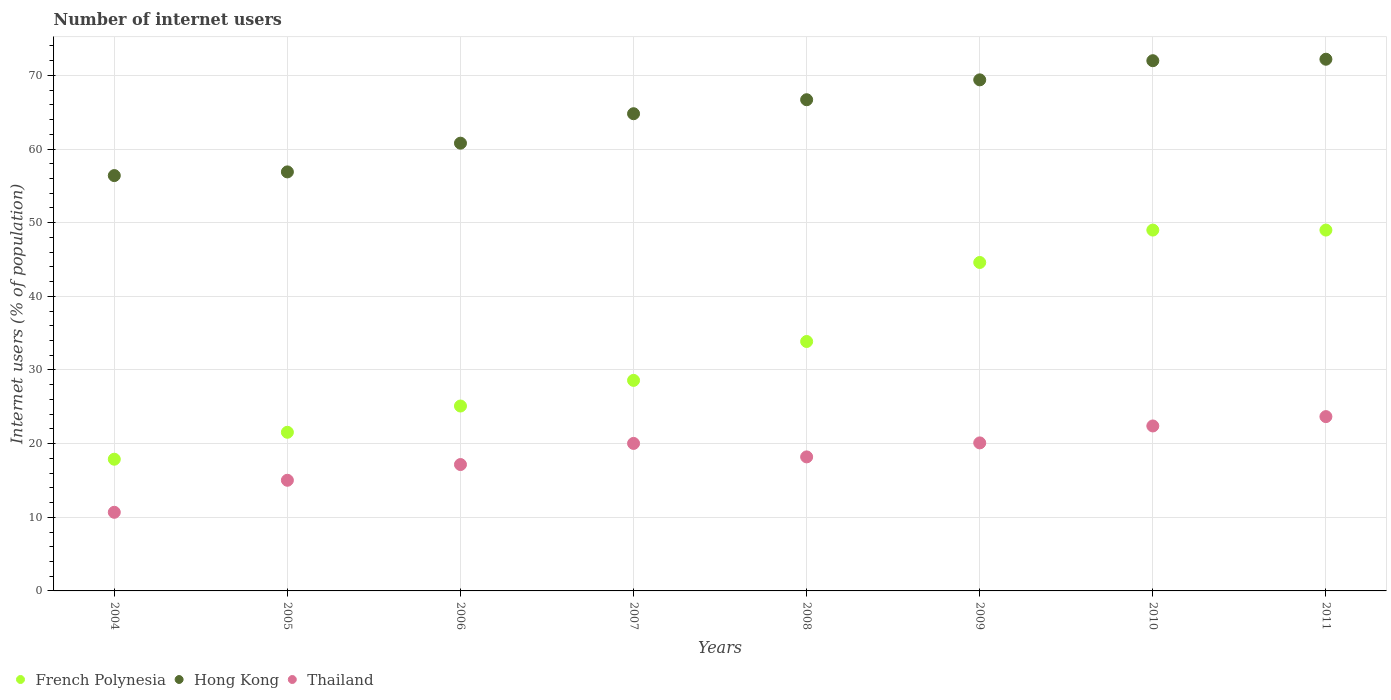How many different coloured dotlines are there?
Your response must be concise. 3. Is the number of dotlines equal to the number of legend labels?
Your answer should be very brief. Yes. What is the number of internet users in Thailand in 2005?
Ensure brevity in your answer.  15.03. Across all years, what is the maximum number of internet users in Thailand?
Give a very brief answer. 23.67. Across all years, what is the minimum number of internet users in Hong Kong?
Provide a short and direct response. 56.4. In which year was the number of internet users in French Polynesia maximum?
Keep it short and to the point. 2010. In which year was the number of internet users in French Polynesia minimum?
Offer a terse response. 2004. What is the total number of internet users in Thailand in the graph?
Your answer should be compact. 147.26. What is the difference between the number of internet users in Thailand in 2004 and that in 2011?
Offer a very short reply. -12.99. What is the difference between the number of internet users in Thailand in 2011 and the number of internet users in Hong Kong in 2009?
Give a very brief answer. -45.73. What is the average number of internet users in Hong Kong per year?
Keep it short and to the point. 64.9. In the year 2010, what is the difference between the number of internet users in Hong Kong and number of internet users in French Polynesia?
Your answer should be compact. 23. What is the ratio of the number of internet users in French Polynesia in 2007 to that in 2009?
Your answer should be compact. 0.64. Is the number of internet users in French Polynesia in 2008 less than that in 2010?
Provide a succinct answer. Yes. What is the difference between the highest and the second highest number of internet users in French Polynesia?
Offer a terse response. 0. What is the difference between the highest and the lowest number of internet users in Thailand?
Your answer should be very brief. 12.99. In how many years, is the number of internet users in French Polynesia greater than the average number of internet users in French Polynesia taken over all years?
Your response must be concise. 4. Is the sum of the number of internet users in Hong Kong in 2004 and 2007 greater than the maximum number of internet users in French Polynesia across all years?
Your answer should be very brief. Yes. Is it the case that in every year, the sum of the number of internet users in Thailand and number of internet users in French Polynesia  is greater than the number of internet users in Hong Kong?
Provide a succinct answer. No. Is the number of internet users in Hong Kong strictly greater than the number of internet users in French Polynesia over the years?
Your response must be concise. Yes. Is the number of internet users in Hong Kong strictly less than the number of internet users in French Polynesia over the years?
Your response must be concise. No. How many dotlines are there?
Give a very brief answer. 3. How many years are there in the graph?
Provide a succinct answer. 8. What is the difference between two consecutive major ticks on the Y-axis?
Your answer should be very brief. 10. Are the values on the major ticks of Y-axis written in scientific E-notation?
Offer a terse response. No. Does the graph contain grids?
Offer a very short reply. Yes. Where does the legend appear in the graph?
Give a very brief answer. Bottom left. How many legend labels are there?
Your answer should be compact. 3. What is the title of the graph?
Offer a terse response. Number of internet users. What is the label or title of the Y-axis?
Offer a terse response. Internet users (% of population). What is the Internet users (% of population) in French Polynesia in 2004?
Ensure brevity in your answer.  17.88. What is the Internet users (% of population) of Hong Kong in 2004?
Your answer should be very brief. 56.4. What is the Internet users (% of population) in Thailand in 2004?
Offer a terse response. 10.68. What is the Internet users (% of population) in French Polynesia in 2005?
Your answer should be compact. 21.54. What is the Internet users (% of population) in Hong Kong in 2005?
Ensure brevity in your answer.  56.9. What is the Internet users (% of population) in Thailand in 2005?
Offer a very short reply. 15.03. What is the Internet users (% of population) of French Polynesia in 2006?
Your answer should be compact. 25.11. What is the Internet users (% of population) of Hong Kong in 2006?
Provide a succinct answer. 60.8. What is the Internet users (% of population) of Thailand in 2006?
Offer a very short reply. 17.16. What is the Internet users (% of population) of French Polynesia in 2007?
Offer a terse response. 28.59. What is the Internet users (% of population) in Hong Kong in 2007?
Ensure brevity in your answer.  64.8. What is the Internet users (% of population) of Thailand in 2007?
Provide a succinct answer. 20.03. What is the Internet users (% of population) of French Polynesia in 2008?
Provide a short and direct response. 33.87. What is the Internet users (% of population) of Hong Kong in 2008?
Ensure brevity in your answer.  66.7. What is the Internet users (% of population) in French Polynesia in 2009?
Your answer should be compact. 44.6. What is the Internet users (% of population) in Hong Kong in 2009?
Provide a succinct answer. 69.4. What is the Internet users (% of population) in Thailand in 2009?
Provide a succinct answer. 20.1. What is the Internet users (% of population) in French Polynesia in 2010?
Provide a succinct answer. 49. What is the Internet users (% of population) of Thailand in 2010?
Ensure brevity in your answer.  22.4. What is the Internet users (% of population) of French Polynesia in 2011?
Provide a succinct answer. 49. What is the Internet users (% of population) in Hong Kong in 2011?
Your response must be concise. 72.2. What is the Internet users (% of population) in Thailand in 2011?
Offer a terse response. 23.67. Across all years, what is the maximum Internet users (% of population) of Hong Kong?
Your answer should be very brief. 72.2. Across all years, what is the maximum Internet users (% of population) of Thailand?
Your response must be concise. 23.67. Across all years, what is the minimum Internet users (% of population) of French Polynesia?
Provide a succinct answer. 17.88. Across all years, what is the minimum Internet users (% of population) of Hong Kong?
Provide a succinct answer. 56.4. Across all years, what is the minimum Internet users (% of population) of Thailand?
Ensure brevity in your answer.  10.68. What is the total Internet users (% of population) in French Polynesia in the graph?
Ensure brevity in your answer.  269.59. What is the total Internet users (% of population) in Hong Kong in the graph?
Your response must be concise. 519.2. What is the total Internet users (% of population) in Thailand in the graph?
Keep it short and to the point. 147.26. What is the difference between the Internet users (% of population) in French Polynesia in 2004 and that in 2005?
Make the answer very short. -3.66. What is the difference between the Internet users (% of population) in Hong Kong in 2004 and that in 2005?
Give a very brief answer. -0.5. What is the difference between the Internet users (% of population) of Thailand in 2004 and that in 2005?
Provide a short and direct response. -4.35. What is the difference between the Internet users (% of population) in French Polynesia in 2004 and that in 2006?
Your answer should be very brief. -7.22. What is the difference between the Internet users (% of population) in Hong Kong in 2004 and that in 2006?
Provide a succinct answer. -4.4. What is the difference between the Internet users (% of population) of Thailand in 2004 and that in 2006?
Offer a very short reply. -6.48. What is the difference between the Internet users (% of population) in French Polynesia in 2004 and that in 2007?
Make the answer very short. -10.71. What is the difference between the Internet users (% of population) of Hong Kong in 2004 and that in 2007?
Offer a terse response. -8.4. What is the difference between the Internet users (% of population) of Thailand in 2004 and that in 2007?
Your answer should be compact. -9.35. What is the difference between the Internet users (% of population) in French Polynesia in 2004 and that in 2008?
Make the answer very short. -15.99. What is the difference between the Internet users (% of population) of Hong Kong in 2004 and that in 2008?
Your answer should be very brief. -10.3. What is the difference between the Internet users (% of population) in Thailand in 2004 and that in 2008?
Make the answer very short. -7.52. What is the difference between the Internet users (% of population) in French Polynesia in 2004 and that in 2009?
Provide a succinct answer. -26.72. What is the difference between the Internet users (% of population) in Hong Kong in 2004 and that in 2009?
Your answer should be compact. -13. What is the difference between the Internet users (% of population) of Thailand in 2004 and that in 2009?
Offer a terse response. -9.42. What is the difference between the Internet users (% of population) of French Polynesia in 2004 and that in 2010?
Your answer should be compact. -31.12. What is the difference between the Internet users (% of population) of Hong Kong in 2004 and that in 2010?
Provide a short and direct response. -15.6. What is the difference between the Internet users (% of population) in Thailand in 2004 and that in 2010?
Your response must be concise. -11.72. What is the difference between the Internet users (% of population) in French Polynesia in 2004 and that in 2011?
Keep it short and to the point. -31.12. What is the difference between the Internet users (% of population) of Hong Kong in 2004 and that in 2011?
Provide a succinct answer. -15.8. What is the difference between the Internet users (% of population) of Thailand in 2004 and that in 2011?
Give a very brief answer. -12.99. What is the difference between the Internet users (% of population) of French Polynesia in 2005 and that in 2006?
Your answer should be very brief. -3.57. What is the difference between the Internet users (% of population) of Hong Kong in 2005 and that in 2006?
Provide a succinct answer. -3.9. What is the difference between the Internet users (% of population) in Thailand in 2005 and that in 2006?
Provide a succinct answer. -2.13. What is the difference between the Internet users (% of population) in French Polynesia in 2005 and that in 2007?
Keep it short and to the point. -7.05. What is the difference between the Internet users (% of population) of Thailand in 2005 and that in 2007?
Ensure brevity in your answer.  -5. What is the difference between the Internet users (% of population) in French Polynesia in 2005 and that in 2008?
Your answer should be compact. -12.33. What is the difference between the Internet users (% of population) in Thailand in 2005 and that in 2008?
Offer a terse response. -3.17. What is the difference between the Internet users (% of population) of French Polynesia in 2005 and that in 2009?
Your answer should be compact. -23.06. What is the difference between the Internet users (% of population) of Thailand in 2005 and that in 2009?
Make the answer very short. -5.07. What is the difference between the Internet users (% of population) in French Polynesia in 2005 and that in 2010?
Keep it short and to the point. -27.46. What is the difference between the Internet users (% of population) of Hong Kong in 2005 and that in 2010?
Give a very brief answer. -15.1. What is the difference between the Internet users (% of population) in Thailand in 2005 and that in 2010?
Make the answer very short. -7.37. What is the difference between the Internet users (% of population) of French Polynesia in 2005 and that in 2011?
Make the answer very short. -27.46. What is the difference between the Internet users (% of population) in Hong Kong in 2005 and that in 2011?
Give a very brief answer. -15.3. What is the difference between the Internet users (% of population) in Thailand in 2005 and that in 2011?
Your answer should be compact. -8.64. What is the difference between the Internet users (% of population) of French Polynesia in 2006 and that in 2007?
Make the answer very short. -3.48. What is the difference between the Internet users (% of population) of Hong Kong in 2006 and that in 2007?
Keep it short and to the point. -4. What is the difference between the Internet users (% of population) of Thailand in 2006 and that in 2007?
Offer a very short reply. -2.87. What is the difference between the Internet users (% of population) in French Polynesia in 2006 and that in 2008?
Your answer should be compact. -8.76. What is the difference between the Internet users (% of population) of Hong Kong in 2006 and that in 2008?
Your answer should be compact. -5.9. What is the difference between the Internet users (% of population) of Thailand in 2006 and that in 2008?
Make the answer very short. -1.04. What is the difference between the Internet users (% of population) in French Polynesia in 2006 and that in 2009?
Provide a short and direct response. -19.49. What is the difference between the Internet users (% of population) in Hong Kong in 2006 and that in 2009?
Your response must be concise. -8.6. What is the difference between the Internet users (% of population) of Thailand in 2006 and that in 2009?
Make the answer very short. -2.94. What is the difference between the Internet users (% of population) in French Polynesia in 2006 and that in 2010?
Your response must be concise. -23.89. What is the difference between the Internet users (% of population) in Hong Kong in 2006 and that in 2010?
Provide a succinct answer. -11.2. What is the difference between the Internet users (% of population) of Thailand in 2006 and that in 2010?
Your response must be concise. -5.24. What is the difference between the Internet users (% of population) of French Polynesia in 2006 and that in 2011?
Provide a short and direct response. -23.89. What is the difference between the Internet users (% of population) in Thailand in 2006 and that in 2011?
Your answer should be compact. -6.51. What is the difference between the Internet users (% of population) of French Polynesia in 2007 and that in 2008?
Ensure brevity in your answer.  -5.28. What is the difference between the Internet users (% of population) in Hong Kong in 2007 and that in 2008?
Your response must be concise. -1.9. What is the difference between the Internet users (% of population) in Thailand in 2007 and that in 2008?
Keep it short and to the point. 1.83. What is the difference between the Internet users (% of population) in French Polynesia in 2007 and that in 2009?
Offer a very short reply. -16.01. What is the difference between the Internet users (% of population) in Thailand in 2007 and that in 2009?
Make the answer very short. -0.07. What is the difference between the Internet users (% of population) of French Polynesia in 2007 and that in 2010?
Give a very brief answer. -20.41. What is the difference between the Internet users (% of population) of Thailand in 2007 and that in 2010?
Give a very brief answer. -2.37. What is the difference between the Internet users (% of population) in French Polynesia in 2007 and that in 2011?
Keep it short and to the point. -20.41. What is the difference between the Internet users (% of population) of Hong Kong in 2007 and that in 2011?
Keep it short and to the point. -7.4. What is the difference between the Internet users (% of population) in Thailand in 2007 and that in 2011?
Your answer should be compact. -3.64. What is the difference between the Internet users (% of population) of French Polynesia in 2008 and that in 2009?
Your response must be concise. -10.73. What is the difference between the Internet users (% of population) of French Polynesia in 2008 and that in 2010?
Your answer should be very brief. -15.13. What is the difference between the Internet users (% of population) of Hong Kong in 2008 and that in 2010?
Provide a succinct answer. -5.3. What is the difference between the Internet users (% of population) of French Polynesia in 2008 and that in 2011?
Keep it short and to the point. -15.13. What is the difference between the Internet users (% of population) in Thailand in 2008 and that in 2011?
Offer a very short reply. -5.47. What is the difference between the Internet users (% of population) of French Polynesia in 2009 and that in 2010?
Your response must be concise. -4.4. What is the difference between the Internet users (% of population) in Hong Kong in 2009 and that in 2010?
Your answer should be compact. -2.6. What is the difference between the Internet users (% of population) in Thailand in 2009 and that in 2011?
Your answer should be compact. -3.57. What is the difference between the Internet users (% of population) of Thailand in 2010 and that in 2011?
Your response must be concise. -1.27. What is the difference between the Internet users (% of population) in French Polynesia in 2004 and the Internet users (% of population) in Hong Kong in 2005?
Ensure brevity in your answer.  -39.02. What is the difference between the Internet users (% of population) in French Polynesia in 2004 and the Internet users (% of population) in Thailand in 2005?
Provide a short and direct response. 2.86. What is the difference between the Internet users (% of population) of Hong Kong in 2004 and the Internet users (% of population) of Thailand in 2005?
Give a very brief answer. 41.37. What is the difference between the Internet users (% of population) of French Polynesia in 2004 and the Internet users (% of population) of Hong Kong in 2006?
Provide a short and direct response. -42.92. What is the difference between the Internet users (% of population) of French Polynesia in 2004 and the Internet users (% of population) of Thailand in 2006?
Keep it short and to the point. 0.72. What is the difference between the Internet users (% of population) of Hong Kong in 2004 and the Internet users (% of population) of Thailand in 2006?
Provide a short and direct response. 39.24. What is the difference between the Internet users (% of population) of French Polynesia in 2004 and the Internet users (% of population) of Hong Kong in 2007?
Offer a very short reply. -46.92. What is the difference between the Internet users (% of population) in French Polynesia in 2004 and the Internet users (% of population) in Thailand in 2007?
Ensure brevity in your answer.  -2.15. What is the difference between the Internet users (% of population) of Hong Kong in 2004 and the Internet users (% of population) of Thailand in 2007?
Give a very brief answer. 36.37. What is the difference between the Internet users (% of population) in French Polynesia in 2004 and the Internet users (% of population) in Hong Kong in 2008?
Make the answer very short. -48.82. What is the difference between the Internet users (% of population) in French Polynesia in 2004 and the Internet users (% of population) in Thailand in 2008?
Your answer should be very brief. -0.32. What is the difference between the Internet users (% of population) of Hong Kong in 2004 and the Internet users (% of population) of Thailand in 2008?
Keep it short and to the point. 38.2. What is the difference between the Internet users (% of population) in French Polynesia in 2004 and the Internet users (% of population) in Hong Kong in 2009?
Offer a terse response. -51.52. What is the difference between the Internet users (% of population) of French Polynesia in 2004 and the Internet users (% of population) of Thailand in 2009?
Your answer should be compact. -2.22. What is the difference between the Internet users (% of population) in Hong Kong in 2004 and the Internet users (% of population) in Thailand in 2009?
Offer a very short reply. 36.3. What is the difference between the Internet users (% of population) in French Polynesia in 2004 and the Internet users (% of population) in Hong Kong in 2010?
Offer a terse response. -54.12. What is the difference between the Internet users (% of population) of French Polynesia in 2004 and the Internet users (% of population) of Thailand in 2010?
Offer a terse response. -4.52. What is the difference between the Internet users (% of population) in Hong Kong in 2004 and the Internet users (% of population) in Thailand in 2010?
Your answer should be compact. 34. What is the difference between the Internet users (% of population) in French Polynesia in 2004 and the Internet users (% of population) in Hong Kong in 2011?
Your answer should be compact. -54.32. What is the difference between the Internet users (% of population) in French Polynesia in 2004 and the Internet users (% of population) in Thailand in 2011?
Ensure brevity in your answer.  -5.79. What is the difference between the Internet users (% of population) in Hong Kong in 2004 and the Internet users (% of population) in Thailand in 2011?
Provide a short and direct response. 32.73. What is the difference between the Internet users (% of population) in French Polynesia in 2005 and the Internet users (% of population) in Hong Kong in 2006?
Your answer should be very brief. -39.26. What is the difference between the Internet users (% of population) in French Polynesia in 2005 and the Internet users (% of population) in Thailand in 2006?
Make the answer very short. 4.38. What is the difference between the Internet users (% of population) of Hong Kong in 2005 and the Internet users (% of population) of Thailand in 2006?
Make the answer very short. 39.74. What is the difference between the Internet users (% of population) of French Polynesia in 2005 and the Internet users (% of population) of Hong Kong in 2007?
Your answer should be very brief. -43.26. What is the difference between the Internet users (% of population) in French Polynesia in 2005 and the Internet users (% of population) in Thailand in 2007?
Make the answer very short. 1.51. What is the difference between the Internet users (% of population) of Hong Kong in 2005 and the Internet users (% of population) of Thailand in 2007?
Offer a very short reply. 36.87. What is the difference between the Internet users (% of population) in French Polynesia in 2005 and the Internet users (% of population) in Hong Kong in 2008?
Your answer should be very brief. -45.16. What is the difference between the Internet users (% of population) in French Polynesia in 2005 and the Internet users (% of population) in Thailand in 2008?
Provide a short and direct response. 3.34. What is the difference between the Internet users (% of population) of Hong Kong in 2005 and the Internet users (% of population) of Thailand in 2008?
Provide a short and direct response. 38.7. What is the difference between the Internet users (% of population) in French Polynesia in 2005 and the Internet users (% of population) in Hong Kong in 2009?
Provide a short and direct response. -47.86. What is the difference between the Internet users (% of population) in French Polynesia in 2005 and the Internet users (% of population) in Thailand in 2009?
Offer a very short reply. 1.44. What is the difference between the Internet users (% of population) of Hong Kong in 2005 and the Internet users (% of population) of Thailand in 2009?
Ensure brevity in your answer.  36.8. What is the difference between the Internet users (% of population) of French Polynesia in 2005 and the Internet users (% of population) of Hong Kong in 2010?
Offer a terse response. -50.46. What is the difference between the Internet users (% of population) in French Polynesia in 2005 and the Internet users (% of population) in Thailand in 2010?
Give a very brief answer. -0.86. What is the difference between the Internet users (% of population) of Hong Kong in 2005 and the Internet users (% of population) of Thailand in 2010?
Offer a terse response. 34.5. What is the difference between the Internet users (% of population) in French Polynesia in 2005 and the Internet users (% of population) in Hong Kong in 2011?
Your response must be concise. -50.66. What is the difference between the Internet users (% of population) of French Polynesia in 2005 and the Internet users (% of population) of Thailand in 2011?
Your response must be concise. -2.13. What is the difference between the Internet users (% of population) in Hong Kong in 2005 and the Internet users (% of population) in Thailand in 2011?
Your response must be concise. 33.23. What is the difference between the Internet users (% of population) of French Polynesia in 2006 and the Internet users (% of population) of Hong Kong in 2007?
Your answer should be very brief. -39.69. What is the difference between the Internet users (% of population) of French Polynesia in 2006 and the Internet users (% of population) of Thailand in 2007?
Your answer should be compact. 5.08. What is the difference between the Internet users (% of population) in Hong Kong in 2006 and the Internet users (% of population) in Thailand in 2007?
Your answer should be compact. 40.77. What is the difference between the Internet users (% of population) of French Polynesia in 2006 and the Internet users (% of population) of Hong Kong in 2008?
Make the answer very short. -41.59. What is the difference between the Internet users (% of population) of French Polynesia in 2006 and the Internet users (% of population) of Thailand in 2008?
Your response must be concise. 6.91. What is the difference between the Internet users (% of population) in Hong Kong in 2006 and the Internet users (% of population) in Thailand in 2008?
Offer a very short reply. 42.6. What is the difference between the Internet users (% of population) of French Polynesia in 2006 and the Internet users (% of population) of Hong Kong in 2009?
Your answer should be compact. -44.29. What is the difference between the Internet users (% of population) of French Polynesia in 2006 and the Internet users (% of population) of Thailand in 2009?
Make the answer very short. 5.01. What is the difference between the Internet users (% of population) of Hong Kong in 2006 and the Internet users (% of population) of Thailand in 2009?
Provide a succinct answer. 40.7. What is the difference between the Internet users (% of population) of French Polynesia in 2006 and the Internet users (% of population) of Hong Kong in 2010?
Give a very brief answer. -46.89. What is the difference between the Internet users (% of population) in French Polynesia in 2006 and the Internet users (% of population) in Thailand in 2010?
Your response must be concise. 2.71. What is the difference between the Internet users (% of population) in Hong Kong in 2006 and the Internet users (% of population) in Thailand in 2010?
Your answer should be compact. 38.4. What is the difference between the Internet users (% of population) of French Polynesia in 2006 and the Internet users (% of population) of Hong Kong in 2011?
Your answer should be compact. -47.09. What is the difference between the Internet users (% of population) in French Polynesia in 2006 and the Internet users (% of population) in Thailand in 2011?
Provide a short and direct response. 1.44. What is the difference between the Internet users (% of population) in Hong Kong in 2006 and the Internet users (% of population) in Thailand in 2011?
Keep it short and to the point. 37.13. What is the difference between the Internet users (% of population) of French Polynesia in 2007 and the Internet users (% of population) of Hong Kong in 2008?
Your answer should be very brief. -38.11. What is the difference between the Internet users (% of population) of French Polynesia in 2007 and the Internet users (% of population) of Thailand in 2008?
Make the answer very short. 10.39. What is the difference between the Internet users (% of population) of Hong Kong in 2007 and the Internet users (% of population) of Thailand in 2008?
Offer a very short reply. 46.6. What is the difference between the Internet users (% of population) of French Polynesia in 2007 and the Internet users (% of population) of Hong Kong in 2009?
Offer a very short reply. -40.81. What is the difference between the Internet users (% of population) in French Polynesia in 2007 and the Internet users (% of population) in Thailand in 2009?
Keep it short and to the point. 8.49. What is the difference between the Internet users (% of population) of Hong Kong in 2007 and the Internet users (% of population) of Thailand in 2009?
Provide a short and direct response. 44.7. What is the difference between the Internet users (% of population) in French Polynesia in 2007 and the Internet users (% of population) in Hong Kong in 2010?
Keep it short and to the point. -43.41. What is the difference between the Internet users (% of population) of French Polynesia in 2007 and the Internet users (% of population) of Thailand in 2010?
Your answer should be compact. 6.19. What is the difference between the Internet users (% of population) in Hong Kong in 2007 and the Internet users (% of population) in Thailand in 2010?
Offer a very short reply. 42.4. What is the difference between the Internet users (% of population) of French Polynesia in 2007 and the Internet users (% of population) of Hong Kong in 2011?
Make the answer very short. -43.61. What is the difference between the Internet users (% of population) in French Polynesia in 2007 and the Internet users (% of population) in Thailand in 2011?
Provide a succinct answer. 4.92. What is the difference between the Internet users (% of population) in Hong Kong in 2007 and the Internet users (% of population) in Thailand in 2011?
Keep it short and to the point. 41.13. What is the difference between the Internet users (% of population) in French Polynesia in 2008 and the Internet users (% of population) in Hong Kong in 2009?
Provide a succinct answer. -35.53. What is the difference between the Internet users (% of population) of French Polynesia in 2008 and the Internet users (% of population) of Thailand in 2009?
Your answer should be very brief. 13.77. What is the difference between the Internet users (% of population) in Hong Kong in 2008 and the Internet users (% of population) in Thailand in 2009?
Provide a short and direct response. 46.6. What is the difference between the Internet users (% of population) in French Polynesia in 2008 and the Internet users (% of population) in Hong Kong in 2010?
Provide a short and direct response. -38.13. What is the difference between the Internet users (% of population) in French Polynesia in 2008 and the Internet users (% of population) in Thailand in 2010?
Your answer should be compact. 11.47. What is the difference between the Internet users (% of population) of Hong Kong in 2008 and the Internet users (% of population) of Thailand in 2010?
Provide a succinct answer. 44.3. What is the difference between the Internet users (% of population) in French Polynesia in 2008 and the Internet users (% of population) in Hong Kong in 2011?
Ensure brevity in your answer.  -38.33. What is the difference between the Internet users (% of population) in French Polynesia in 2008 and the Internet users (% of population) in Thailand in 2011?
Make the answer very short. 10.2. What is the difference between the Internet users (% of population) in Hong Kong in 2008 and the Internet users (% of population) in Thailand in 2011?
Provide a succinct answer. 43.03. What is the difference between the Internet users (% of population) of French Polynesia in 2009 and the Internet users (% of population) of Hong Kong in 2010?
Provide a succinct answer. -27.4. What is the difference between the Internet users (% of population) in Hong Kong in 2009 and the Internet users (% of population) in Thailand in 2010?
Make the answer very short. 47. What is the difference between the Internet users (% of population) in French Polynesia in 2009 and the Internet users (% of population) in Hong Kong in 2011?
Give a very brief answer. -27.6. What is the difference between the Internet users (% of population) of French Polynesia in 2009 and the Internet users (% of population) of Thailand in 2011?
Your response must be concise. 20.93. What is the difference between the Internet users (% of population) in Hong Kong in 2009 and the Internet users (% of population) in Thailand in 2011?
Make the answer very short. 45.73. What is the difference between the Internet users (% of population) of French Polynesia in 2010 and the Internet users (% of population) of Hong Kong in 2011?
Keep it short and to the point. -23.2. What is the difference between the Internet users (% of population) in French Polynesia in 2010 and the Internet users (% of population) in Thailand in 2011?
Your answer should be compact. 25.33. What is the difference between the Internet users (% of population) in Hong Kong in 2010 and the Internet users (% of population) in Thailand in 2011?
Provide a short and direct response. 48.33. What is the average Internet users (% of population) in French Polynesia per year?
Your answer should be very brief. 33.7. What is the average Internet users (% of population) in Hong Kong per year?
Your answer should be very brief. 64.9. What is the average Internet users (% of population) of Thailand per year?
Provide a short and direct response. 18.41. In the year 2004, what is the difference between the Internet users (% of population) of French Polynesia and Internet users (% of population) of Hong Kong?
Your response must be concise. -38.52. In the year 2004, what is the difference between the Internet users (% of population) of French Polynesia and Internet users (% of population) of Thailand?
Provide a short and direct response. 7.21. In the year 2004, what is the difference between the Internet users (% of population) in Hong Kong and Internet users (% of population) in Thailand?
Provide a short and direct response. 45.72. In the year 2005, what is the difference between the Internet users (% of population) of French Polynesia and Internet users (% of population) of Hong Kong?
Make the answer very short. -35.36. In the year 2005, what is the difference between the Internet users (% of population) in French Polynesia and Internet users (% of population) in Thailand?
Provide a short and direct response. 6.52. In the year 2005, what is the difference between the Internet users (% of population) in Hong Kong and Internet users (% of population) in Thailand?
Your answer should be very brief. 41.87. In the year 2006, what is the difference between the Internet users (% of population) of French Polynesia and Internet users (% of population) of Hong Kong?
Keep it short and to the point. -35.69. In the year 2006, what is the difference between the Internet users (% of population) in French Polynesia and Internet users (% of population) in Thailand?
Provide a succinct answer. 7.95. In the year 2006, what is the difference between the Internet users (% of population) in Hong Kong and Internet users (% of population) in Thailand?
Ensure brevity in your answer.  43.64. In the year 2007, what is the difference between the Internet users (% of population) in French Polynesia and Internet users (% of population) in Hong Kong?
Your answer should be compact. -36.21. In the year 2007, what is the difference between the Internet users (% of population) in French Polynesia and Internet users (% of population) in Thailand?
Give a very brief answer. 8.56. In the year 2007, what is the difference between the Internet users (% of population) in Hong Kong and Internet users (% of population) in Thailand?
Provide a succinct answer. 44.77. In the year 2008, what is the difference between the Internet users (% of population) of French Polynesia and Internet users (% of population) of Hong Kong?
Offer a very short reply. -32.83. In the year 2008, what is the difference between the Internet users (% of population) of French Polynesia and Internet users (% of population) of Thailand?
Give a very brief answer. 15.67. In the year 2008, what is the difference between the Internet users (% of population) of Hong Kong and Internet users (% of population) of Thailand?
Your answer should be very brief. 48.5. In the year 2009, what is the difference between the Internet users (% of population) in French Polynesia and Internet users (% of population) in Hong Kong?
Your answer should be compact. -24.8. In the year 2009, what is the difference between the Internet users (% of population) of French Polynesia and Internet users (% of population) of Thailand?
Offer a terse response. 24.5. In the year 2009, what is the difference between the Internet users (% of population) in Hong Kong and Internet users (% of population) in Thailand?
Your response must be concise. 49.3. In the year 2010, what is the difference between the Internet users (% of population) of French Polynesia and Internet users (% of population) of Hong Kong?
Provide a short and direct response. -23. In the year 2010, what is the difference between the Internet users (% of population) of French Polynesia and Internet users (% of population) of Thailand?
Keep it short and to the point. 26.6. In the year 2010, what is the difference between the Internet users (% of population) in Hong Kong and Internet users (% of population) in Thailand?
Keep it short and to the point. 49.6. In the year 2011, what is the difference between the Internet users (% of population) in French Polynesia and Internet users (% of population) in Hong Kong?
Give a very brief answer. -23.2. In the year 2011, what is the difference between the Internet users (% of population) in French Polynesia and Internet users (% of population) in Thailand?
Your response must be concise. 25.33. In the year 2011, what is the difference between the Internet users (% of population) of Hong Kong and Internet users (% of population) of Thailand?
Your answer should be very brief. 48.53. What is the ratio of the Internet users (% of population) of French Polynesia in 2004 to that in 2005?
Your answer should be compact. 0.83. What is the ratio of the Internet users (% of population) of Hong Kong in 2004 to that in 2005?
Ensure brevity in your answer.  0.99. What is the ratio of the Internet users (% of population) in Thailand in 2004 to that in 2005?
Keep it short and to the point. 0.71. What is the ratio of the Internet users (% of population) in French Polynesia in 2004 to that in 2006?
Keep it short and to the point. 0.71. What is the ratio of the Internet users (% of population) in Hong Kong in 2004 to that in 2006?
Your response must be concise. 0.93. What is the ratio of the Internet users (% of population) of Thailand in 2004 to that in 2006?
Give a very brief answer. 0.62. What is the ratio of the Internet users (% of population) of French Polynesia in 2004 to that in 2007?
Your response must be concise. 0.63. What is the ratio of the Internet users (% of population) of Hong Kong in 2004 to that in 2007?
Provide a succinct answer. 0.87. What is the ratio of the Internet users (% of population) in Thailand in 2004 to that in 2007?
Your answer should be compact. 0.53. What is the ratio of the Internet users (% of population) of French Polynesia in 2004 to that in 2008?
Keep it short and to the point. 0.53. What is the ratio of the Internet users (% of population) in Hong Kong in 2004 to that in 2008?
Provide a succinct answer. 0.85. What is the ratio of the Internet users (% of population) of Thailand in 2004 to that in 2008?
Provide a succinct answer. 0.59. What is the ratio of the Internet users (% of population) of French Polynesia in 2004 to that in 2009?
Provide a succinct answer. 0.4. What is the ratio of the Internet users (% of population) of Hong Kong in 2004 to that in 2009?
Keep it short and to the point. 0.81. What is the ratio of the Internet users (% of population) of Thailand in 2004 to that in 2009?
Ensure brevity in your answer.  0.53. What is the ratio of the Internet users (% of population) of French Polynesia in 2004 to that in 2010?
Provide a succinct answer. 0.36. What is the ratio of the Internet users (% of population) in Hong Kong in 2004 to that in 2010?
Your response must be concise. 0.78. What is the ratio of the Internet users (% of population) in Thailand in 2004 to that in 2010?
Offer a terse response. 0.48. What is the ratio of the Internet users (% of population) in French Polynesia in 2004 to that in 2011?
Provide a short and direct response. 0.36. What is the ratio of the Internet users (% of population) of Hong Kong in 2004 to that in 2011?
Your answer should be very brief. 0.78. What is the ratio of the Internet users (% of population) of Thailand in 2004 to that in 2011?
Offer a very short reply. 0.45. What is the ratio of the Internet users (% of population) in French Polynesia in 2005 to that in 2006?
Keep it short and to the point. 0.86. What is the ratio of the Internet users (% of population) of Hong Kong in 2005 to that in 2006?
Provide a succinct answer. 0.94. What is the ratio of the Internet users (% of population) of Thailand in 2005 to that in 2006?
Offer a terse response. 0.88. What is the ratio of the Internet users (% of population) of French Polynesia in 2005 to that in 2007?
Provide a short and direct response. 0.75. What is the ratio of the Internet users (% of population) in Hong Kong in 2005 to that in 2007?
Make the answer very short. 0.88. What is the ratio of the Internet users (% of population) of Thailand in 2005 to that in 2007?
Give a very brief answer. 0.75. What is the ratio of the Internet users (% of population) of French Polynesia in 2005 to that in 2008?
Offer a very short reply. 0.64. What is the ratio of the Internet users (% of population) of Hong Kong in 2005 to that in 2008?
Your answer should be compact. 0.85. What is the ratio of the Internet users (% of population) of Thailand in 2005 to that in 2008?
Your response must be concise. 0.83. What is the ratio of the Internet users (% of population) in French Polynesia in 2005 to that in 2009?
Your answer should be very brief. 0.48. What is the ratio of the Internet users (% of population) in Hong Kong in 2005 to that in 2009?
Your answer should be very brief. 0.82. What is the ratio of the Internet users (% of population) in Thailand in 2005 to that in 2009?
Give a very brief answer. 0.75. What is the ratio of the Internet users (% of population) of French Polynesia in 2005 to that in 2010?
Your answer should be very brief. 0.44. What is the ratio of the Internet users (% of population) in Hong Kong in 2005 to that in 2010?
Provide a short and direct response. 0.79. What is the ratio of the Internet users (% of population) of Thailand in 2005 to that in 2010?
Your answer should be very brief. 0.67. What is the ratio of the Internet users (% of population) in French Polynesia in 2005 to that in 2011?
Your answer should be very brief. 0.44. What is the ratio of the Internet users (% of population) in Hong Kong in 2005 to that in 2011?
Offer a terse response. 0.79. What is the ratio of the Internet users (% of population) of Thailand in 2005 to that in 2011?
Offer a very short reply. 0.63. What is the ratio of the Internet users (% of population) of French Polynesia in 2006 to that in 2007?
Provide a succinct answer. 0.88. What is the ratio of the Internet users (% of population) of Hong Kong in 2006 to that in 2007?
Make the answer very short. 0.94. What is the ratio of the Internet users (% of population) of Thailand in 2006 to that in 2007?
Provide a short and direct response. 0.86. What is the ratio of the Internet users (% of population) in French Polynesia in 2006 to that in 2008?
Offer a very short reply. 0.74. What is the ratio of the Internet users (% of population) in Hong Kong in 2006 to that in 2008?
Provide a short and direct response. 0.91. What is the ratio of the Internet users (% of population) in Thailand in 2006 to that in 2008?
Your response must be concise. 0.94. What is the ratio of the Internet users (% of population) in French Polynesia in 2006 to that in 2009?
Ensure brevity in your answer.  0.56. What is the ratio of the Internet users (% of population) in Hong Kong in 2006 to that in 2009?
Make the answer very short. 0.88. What is the ratio of the Internet users (% of population) of Thailand in 2006 to that in 2009?
Make the answer very short. 0.85. What is the ratio of the Internet users (% of population) in French Polynesia in 2006 to that in 2010?
Offer a very short reply. 0.51. What is the ratio of the Internet users (% of population) in Hong Kong in 2006 to that in 2010?
Provide a short and direct response. 0.84. What is the ratio of the Internet users (% of population) of Thailand in 2006 to that in 2010?
Your answer should be very brief. 0.77. What is the ratio of the Internet users (% of population) in French Polynesia in 2006 to that in 2011?
Your answer should be very brief. 0.51. What is the ratio of the Internet users (% of population) in Hong Kong in 2006 to that in 2011?
Offer a terse response. 0.84. What is the ratio of the Internet users (% of population) of Thailand in 2006 to that in 2011?
Ensure brevity in your answer.  0.72. What is the ratio of the Internet users (% of population) of French Polynesia in 2007 to that in 2008?
Provide a succinct answer. 0.84. What is the ratio of the Internet users (% of population) in Hong Kong in 2007 to that in 2008?
Your response must be concise. 0.97. What is the ratio of the Internet users (% of population) in Thailand in 2007 to that in 2008?
Offer a very short reply. 1.1. What is the ratio of the Internet users (% of population) of French Polynesia in 2007 to that in 2009?
Keep it short and to the point. 0.64. What is the ratio of the Internet users (% of population) in Hong Kong in 2007 to that in 2009?
Your answer should be compact. 0.93. What is the ratio of the Internet users (% of population) of French Polynesia in 2007 to that in 2010?
Provide a succinct answer. 0.58. What is the ratio of the Internet users (% of population) in Hong Kong in 2007 to that in 2010?
Your answer should be very brief. 0.9. What is the ratio of the Internet users (% of population) of Thailand in 2007 to that in 2010?
Keep it short and to the point. 0.89. What is the ratio of the Internet users (% of population) in French Polynesia in 2007 to that in 2011?
Give a very brief answer. 0.58. What is the ratio of the Internet users (% of population) in Hong Kong in 2007 to that in 2011?
Your answer should be compact. 0.9. What is the ratio of the Internet users (% of population) of Thailand in 2007 to that in 2011?
Your answer should be very brief. 0.85. What is the ratio of the Internet users (% of population) of French Polynesia in 2008 to that in 2009?
Offer a very short reply. 0.76. What is the ratio of the Internet users (% of population) of Hong Kong in 2008 to that in 2009?
Offer a terse response. 0.96. What is the ratio of the Internet users (% of population) of Thailand in 2008 to that in 2009?
Ensure brevity in your answer.  0.91. What is the ratio of the Internet users (% of population) in French Polynesia in 2008 to that in 2010?
Provide a short and direct response. 0.69. What is the ratio of the Internet users (% of population) of Hong Kong in 2008 to that in 2010?
Offer a terse response. 0.93. What is the ratio of the Internet users (% of population) of Thailand in 2008 to that in 2010?
Give a very brief answer. 0.81. What is the ratio of the Internet users (% of population) of French Polynesia in 2008 to that in 2011?
Give a very brief answer. 0.69. What is the ratio of the Internet users (% of population) in Hong Kong in 2008 to that in 2011?
Your answer should be very brief. 0.92. What is the ratio of the Internet users (% of population) in Thailand in 2008 to that in 2011?
Ensure brevity in your answer.  0.77. What is the ratio of the Internet users (% of population) of French Polynesia in 2009 to that in 2010?
Give a very brief answer. 0.91. What is the ratio of the Internet users (% of population) of Hong Kong in 2009 to that in 2010?
Keep it short and to the point. 0.96. What is the ratio of the Internet users (% of population) of Thailand in 2009 to that in 2010?
Your answer should be compact. 0.9. What is the ratio of the Internet users (% of population) in French Polynesia in 2009 to that in 2011?
Provide a succinct answer. 0.91. What is the ratio of the Internet users (% of population) of Hong Kong in 2009 to that in 2011?
Keep it short and to the point. 0.96. What is the ratio of the Internet users (% of population) in Thailand in 2009 to that in 2011?
Offer a terse response. 0.85. What is the ratio of the Internet users (% of population) in Hong Kong in 2010 to that in 2011?
Give a very brief answer. 1. What is the ratio of the Internet users (% of population) of Thailand in 2010 to that in 2011?
Give a very brief answer. 0.95. What is the difference between the highest and the second highest Internet users (% of population) in Hong Kong?
Offer a terse response. 0.2. What is the difference between the highest and the second highest Internet users (% of population) in Thailand?
Your answer should be very brief. 1.27. What is the difference between the highest and the lowest Internet users (% of population) in French Polynesia?
Provide a short and direct response. 31.12. What is the difference between the highest and the lowest Internet users (% of population) of Hong Kong?
Ensure brevity in your answer.  15.8. What is the difference between the highest and the lowest Internet users (% of population) in Thailand?
Your answer should be compact. 12.99. 